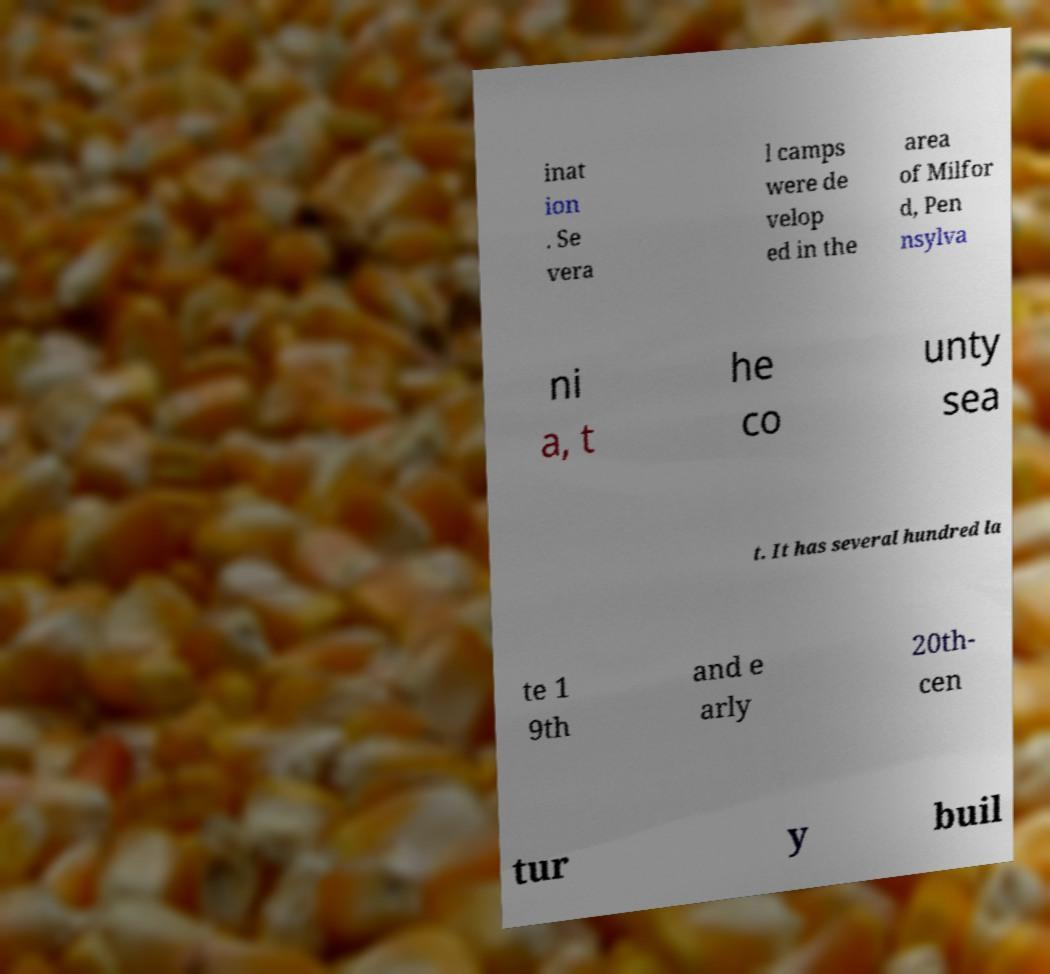There's text embedded in this image that I need extracted. Can you transcribe it verbatim? inat ion . Se vera l camps were de velop ed in the area of Milfor d, Pen nsylva ni a, t he co unty sea t. It has several hundred la te 1 9th and e arly 20th- cen tur y buil 